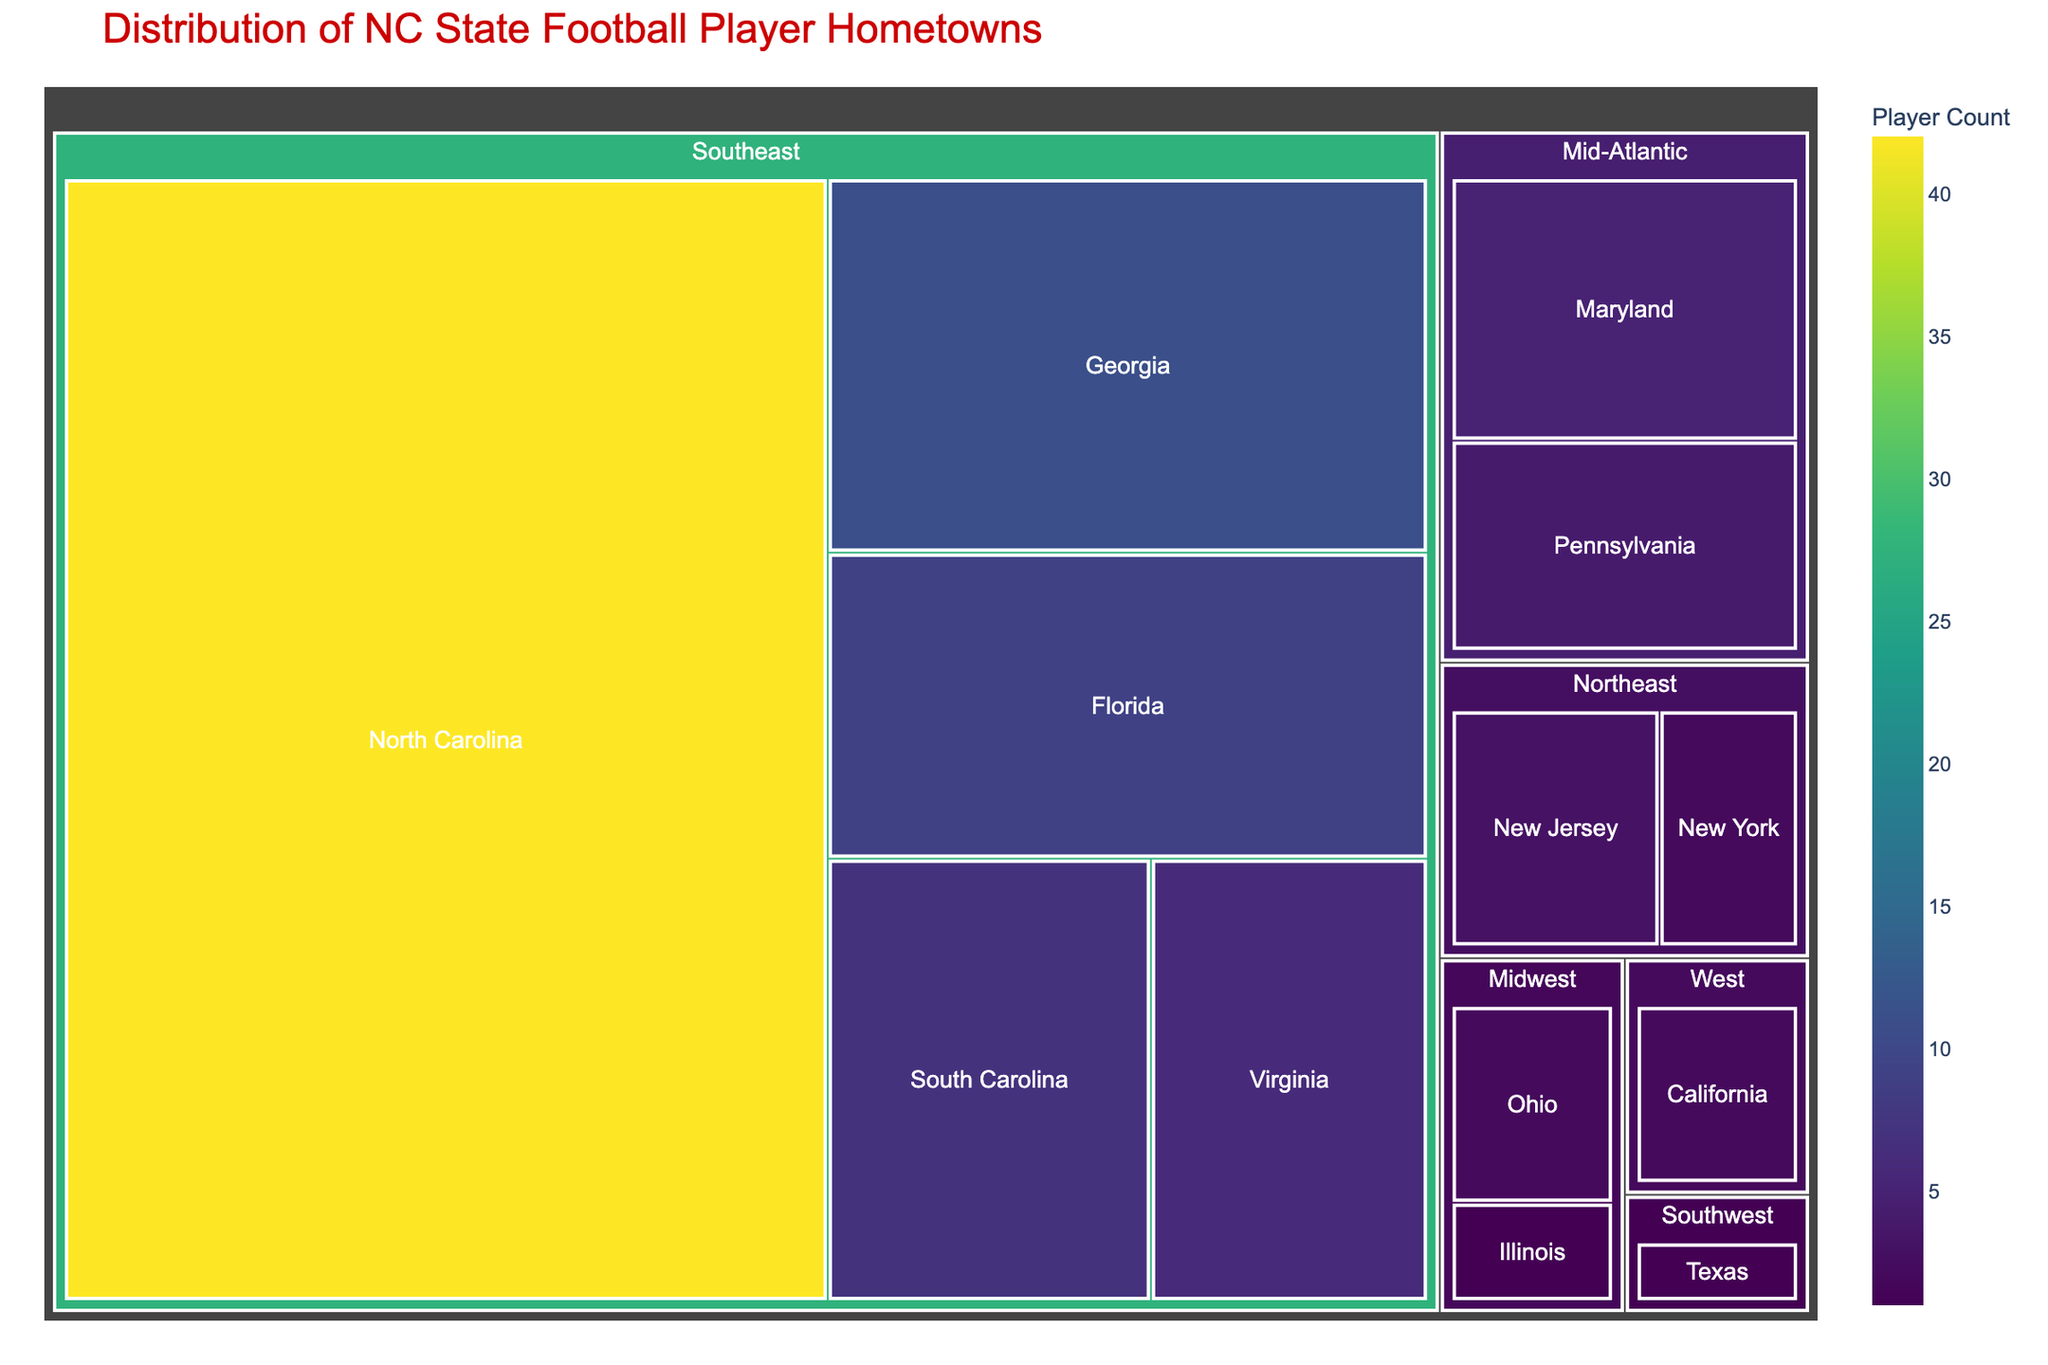What's the title of the figure? The title is typically found at the top of the figure and provides a brief description of what the chart represents.
Answer: Distribution of NC State Football Player Hometowns How many players come from the Midwest region? To find the number of players from the Midwest, sum the counts for the states within the Midwest region (Ohio and Illinois).
Answer: 3 Which state has the highest number of NC State football players? To determine the state with the highest player count, observe the size of the rectangles and their corresponding values. North Carolina has the largest rectangle and the highest count.
Answer: North Carolina What is the combined total of players from the Southeast region? To find the total players from the Southeast region, sum the counts of the states within this region (North Carolina, Georgia, Florida, South Carolina, Virginia).
Answer: 75 Compare the number of players from Georgia and New York. Which state has more players? Compare the counts of players from Georgia and New York provided in the figure. Georgia has 11 players, while New York has 2 players.
Answer: Georgia How many regions are represented in the figure? Count the number of unique regions listed in the figure.
Answer: 5 Is the number of players from Maryland greater than from Pennsylvania? Compare the counts for Maryland and Pennsylvania. Maryland has 5 players and Pennsylvania has 4 players.
Answer: Yes Which state in the Midwest has the fewest number of players? Out of the Midwest states listed (Ohio and Illinois), Illinois has the fewest players with 1.
Answer: Illinois What is the smallest player count among all states? Identify the smallest number from the counts of all states. Illinois and Texas both have 1 player.
Answer: 1 How many states have more than 5 players? Count the number of states with a player count greater than 5. States with more than 5 players are North Carolina, Georgia, Florida, South Carolina, Virginia, and Maryland.
Answer: 6 